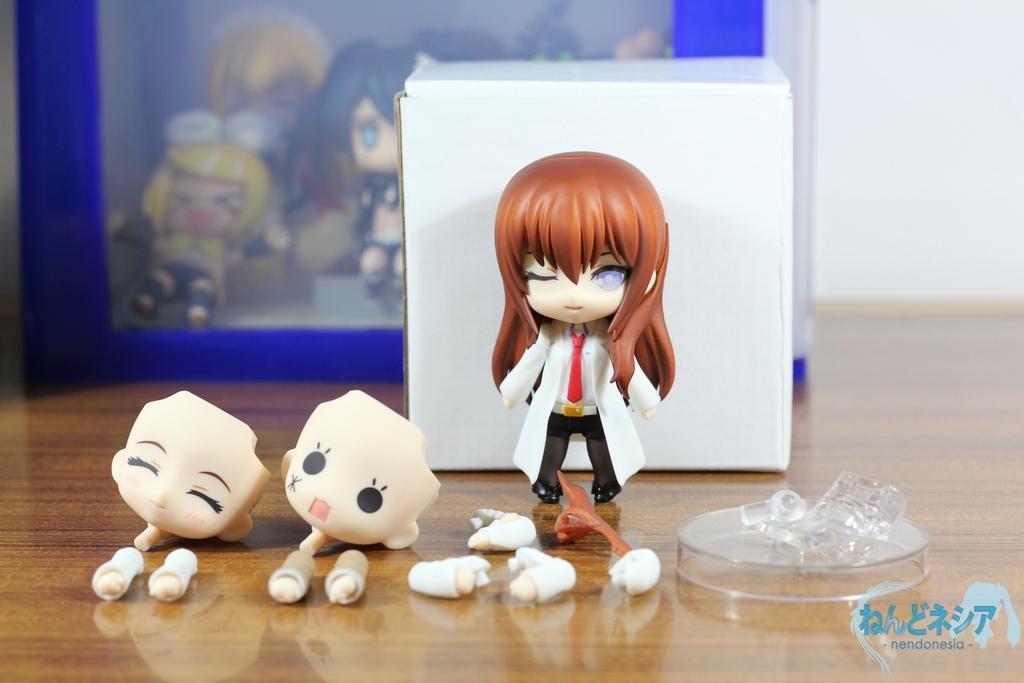Please provide a concise description of this image. In this image we can see toys and a photo frame on the floor. 